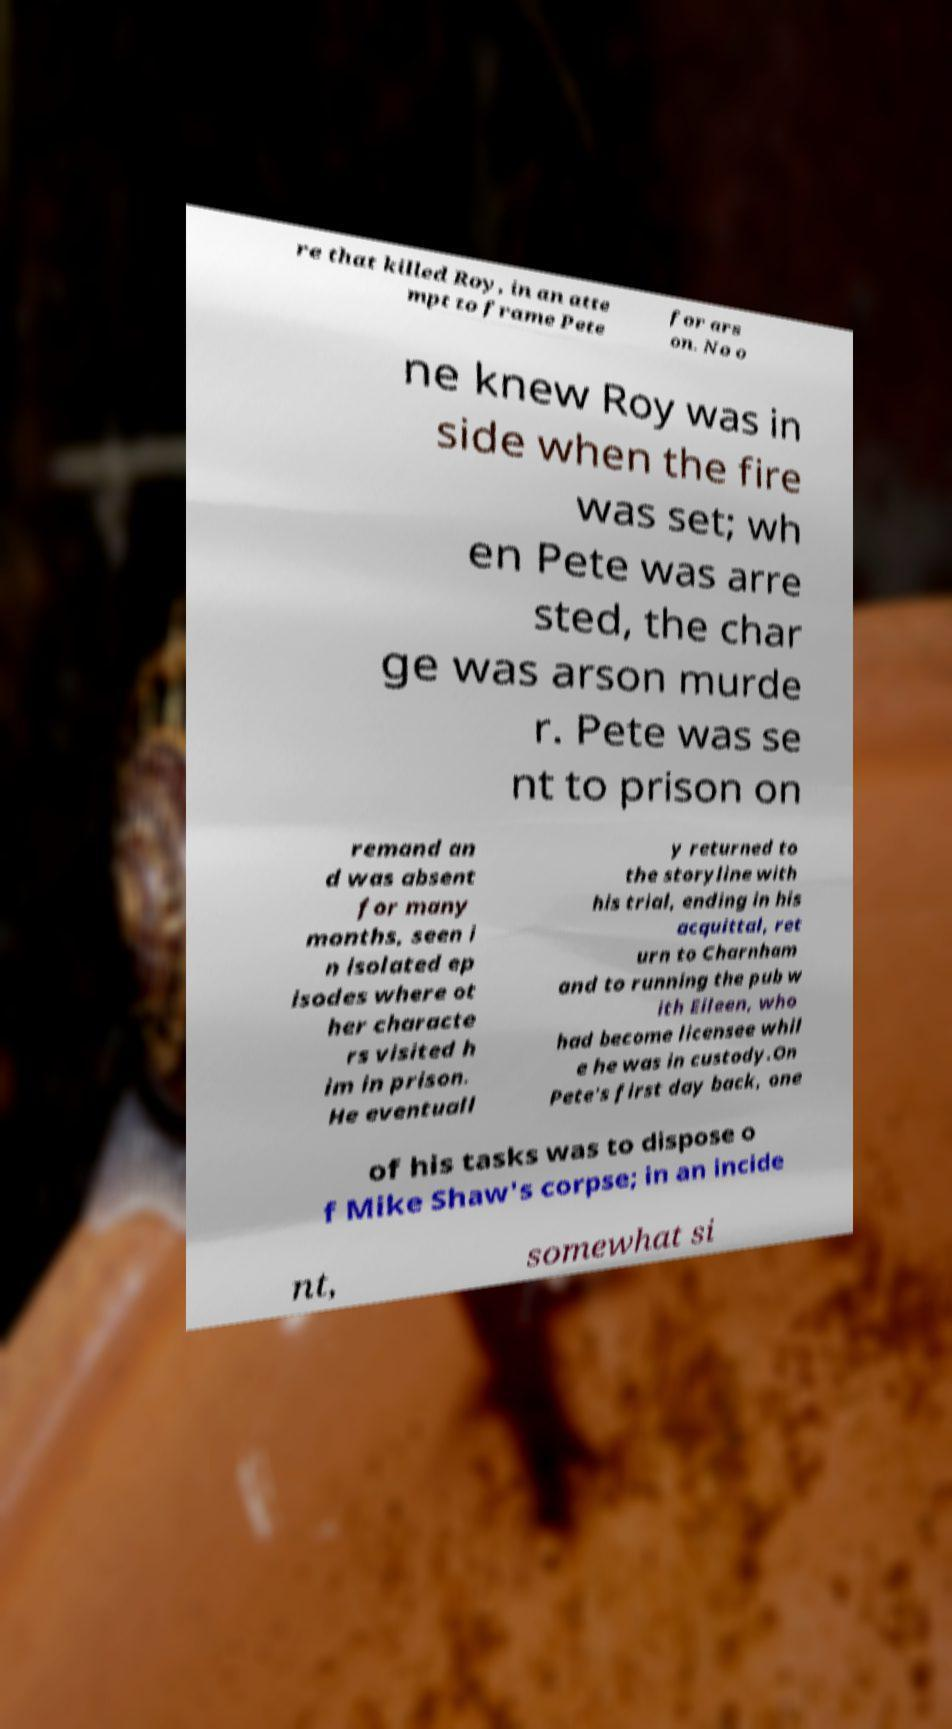Could you extract and type out the text from this image? re that killed Roy, in an atte mpt to frame Pete for ars on. No o ne knew Roy was in side when the fire was set; wh en Pete was arre sted, the char ge was arson murde r. Pete was se nt to prison on remand an d was absent for many months, seen i n isolated ep isodes where ot her characte rs visited h im in prison. He eventuall y returned to the storyline with his trial, ending in his acquittal, ret urn to Charnham and to running the pub w ith Eileen, who had become licensee whil e he was in custody.On Pete's first day back, one of his tasks was to dispose o f Mike Shaw's corpse; in an incide nt, somewhat si 